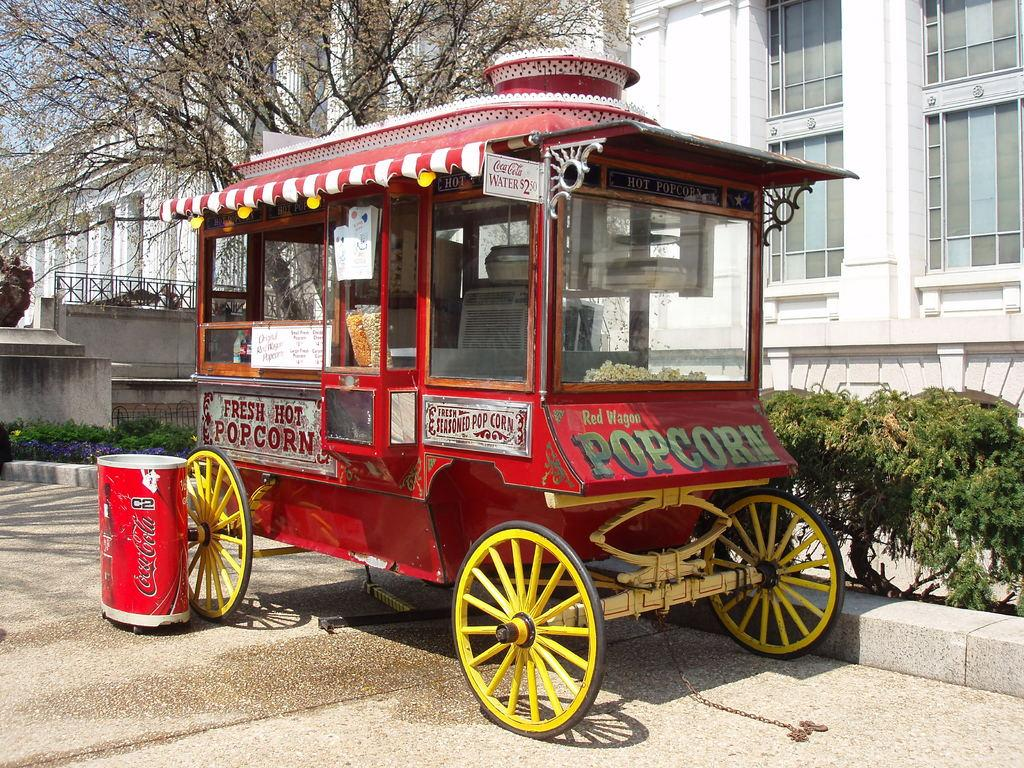What is the main subject in the picture? There is a vehicle in the picture. What other objects can be seen in the image? There is a dustbin, plants, a white building, and a tree in the picture. What is the color of the building in the picture? The building in the picture is white. What can be seen in the background of the picture? The sky is visible in the background of the picture. What type of meal is being prepared in the house in the picture? There is no house present in the image, and therefore no meal preparation can be observed. 